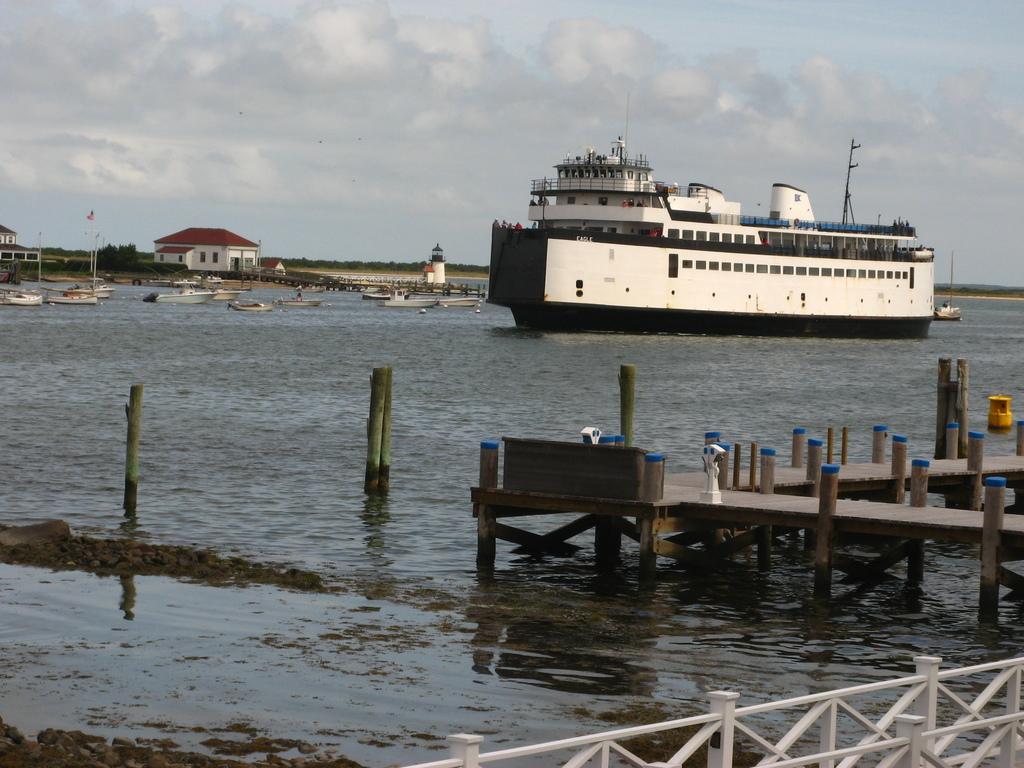Please provide a concise description of this image. In this image I can see the lake , on the lake I can see ship , on the right side I can see a house and at the top I can see the sky, at the bottom I can see a fence and on the right side I can see a small bridge and poles visible. 